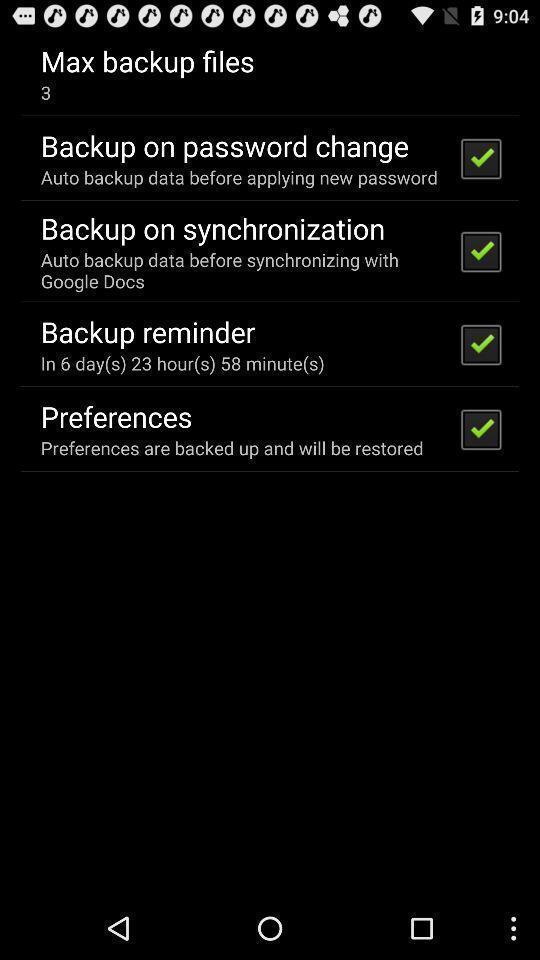Provide a textual representation of this image. Page that displaying list of settings. 